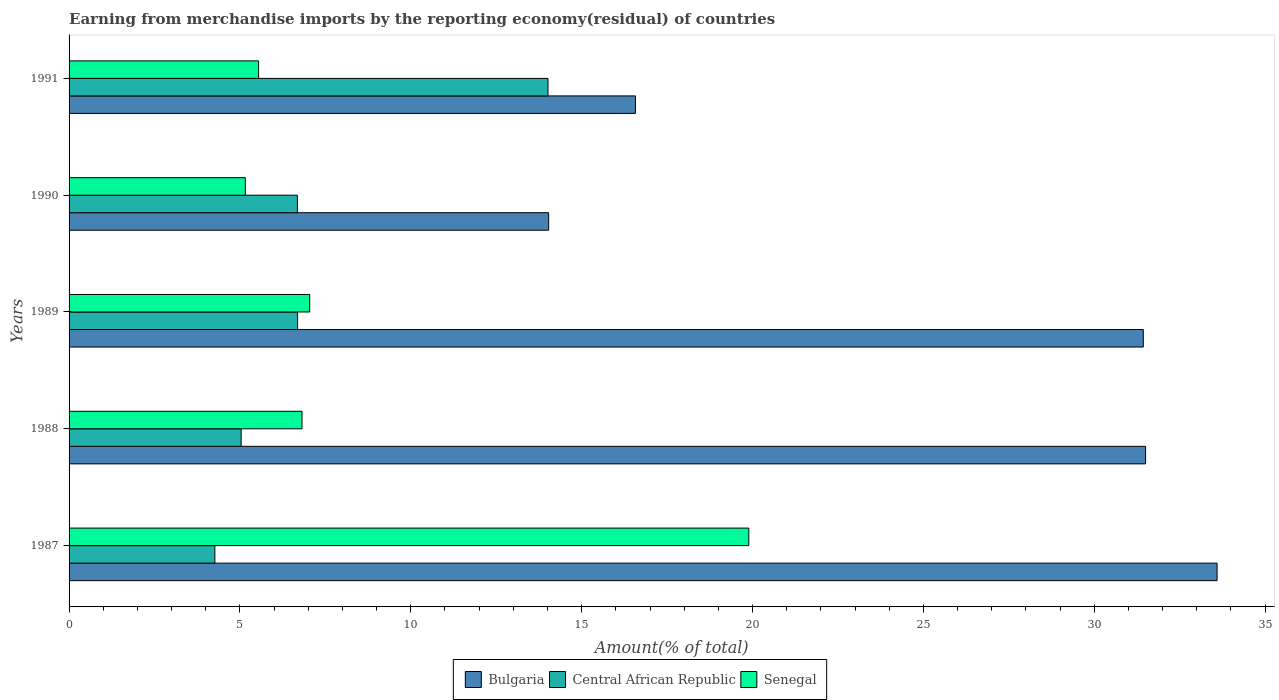How many different coloured bars are there?
Make the answer very short. 3. How many groups of bars are there?
Provide a short and direct response. 5. Are the number of bars per tick equal to the number of legend labels?
Ensure brevity in your answer.  Yes. Are the number of bars on each tick of the Y-axis equal?
Keep it short and to the point. Yes. How many bars are there on the 2nd tick from the bottom?
Ensure brevity in your answer.  3. In how many cases, is the number of bars for a given year not equal to the number of legend labels?
Offer a very short reply. 0. What is the percentage of amount earned from merchandise imports in Senegal in 1989?
Give a very brief answer. 7.04. Across all years, what is the maximum percentage of amount earned from merchandise imports in Senegal?
Your answer should be very brief. 19.89. Across all years, what is the minimum percentage of amount earned from merchandise imports in Bulgaria?
Offer a terse response. 14.03. In which year was the percentage of amount earned from merchandise imports in Senegal maximum?
Keep it short and to the point. 1987. In which year was the percentage of amount earned from merchandise imports in Senegal minimum?
Make the answer very short. 1990. What is the total percentage of amount earned from merchandise imports in Bulgaria in the graph?
Make the answer very short. 127.14. What is the difference between the percentage of amount earned from merchandise imports in Senegal in 1987 and that in 1988?
Offer a very short reply. 13.07. What is the difference between the percentage of amount earned from merchandise imports in Senegal in 1990 and the percentage of amount earned from merchandise imports in Central African Republic in 1991?
Offer a terse response. -8.86. What is the average percentage of amount earned from merchandise imports in Central African Republic per year?
Ensure brevity in your answer.  7.34. In the year 1989, what is the difference between the percentage of amount earned from merchandise imports in Bulgaria and percentage of amount earned from merchandise imports in Central African Republic?
Your answer should be compact. 24.75. In how many years, is the percentage of amount earned from merchandise imports in Bulgaria greater than 21 %?
Ensure brevity in your answer.  3. What is the ratio of the percentage of amount earned from merchandise imports in Senegal in 1987 to that in 1991?
Ensure brevity in your answer.  3.59. Is the percentage of amount earned from merchandise imports in Bulgaria in 1987 less than that in 1991?
Offer a terse response. No. What is the difference between the highest and the second highest percentage of amount earned from merchandise imports in Central African Republic?
Your answer should be very brief. 7.33. What is the difference between the highest and the lowest percentage of amount earned from merchandise imports in Bulgaria?
Offer a very short reply. 19.56. Is the sum of the percentage of amount earned from merchandise imports in Bulgaria in 1987 and 1991 greater than the maximum percentage of amount earned from merchandise imports in Central African Republic across all years?
Your response must be concise. Yes. What does the 2nd bar from the bottom in 1991 represents?
Provide a succinct answer. Central African Republic. Is it the case that in every year, the sum of the percentage of amount earned from merchandise imports in Bulgaria and percentage of amount earned from merchandise imports in Senegal is greater than the percentage of amount earned from merchandise imports in Central African Republic?
Your answer should be very brief. Yes. How many bars are there?
Offer a terse response. 15. Are all the bars in the graph horizontal?
Your answer should be compact. Yes. How many years are there in the graph?
Provide a short and direct response. 5. Does the graph contain grids?
Provide a succinct answer. No. Where does the legend appear in the graph?
Make the answer very short. Bottom center. How are the legend labels stacked?
Your answer should be very brief. Horizontal. What is the title of the graph?
Provide a succinct answer. Earning from merchandise imports by the reporting economy(residual) of countries. What is the label or title of the X-axis?
Offer a terse response. Amount(% of total). What is the Amount(% of total) in Bulgaria in 1987?
Keep it short and to the point. 33.59. What is the Amount(% of total) in Central African Republic in 1987?
Provide a succinct answer. 4.27. What is the Amount(% of total) of Senegal in 1987?
Offer a terse response. 19.89. What is the Amount(% of total) in Bulgaria in 1988?
Your answer should be very brief. 31.5. What is the Amount(% of total) of Central African Republic in 1988?
Ensure brevity in your answer.  5.04. What is the Amount(% of total) in Senegal in 1988?
Make the answer very short. 6.82. What is the Amount(% of total) in Bulgaria in 1989?
Ensure brevity in your answer.  31.44. What is the Amount(% of total) of Central African Republic in 1989?
Make the answer very short. 6.69. What is the Amount(% of total) in Senegal in 1989?
Your answer should be very brief. 7.04. What is the Amount(% of total) in Bulgaria in 1990?
Keep it short and to the point. 14.03. What is the Amount(% of total) in Central African Republic in 1990?
Offer a very short reply. 6.68. What is the Amount(% of total) in Senegal in 1990?
Keep it short and to the point. 5.16. What is the Amount(% of total) of Bulgaria in 1991?
Ensure brevity in your answer.  16.58. What is the Amount(% of total) in Central African Republic in 1991?
Give a very brief answer. 14.02. What is the Amount(% of total) in Senegal in 1991?
Your answer should be compact. 5.55. Across all years, what is the maximum Amount(% of total) of Bulgaria?
Give a very brief answer. 33.59. Across all years, what is the maximum Amount(% of total) in Central African Republic?
Your response must be concise. 14.02. Across all years, what is the maximum Amount(% of total) of Senegal?
Offer a terse response. 19.89. Across all years, what is the minimum Amount(% of total) in Bulgaria?
Make the answer very short. 14.03. Across all years, what is the minimum Amount(% of total) in Central African Republic?
Offer a very short reply. 4.27. Across all years, what is the minimum Amount(% of total) in Senegal?
Provide a succinct answer. 5.16. What is the total Amount(% of total) in Bulgaria in the graph?
Provide a succinct answer. 127.14. What is the total Amount(% of total) of Central African Republic in the graph?
Offer a very short reply. 36.69. What is the total Amount(% of total) in Senegal in the graph?
Ensure brevity in your answer.  44.45. What is the difference between the Amount(% of total) of Bulgaria in 1987 and that in 1988?
Your answer should be very brief. 2.09. What is the difference between the Amount(% of total) in Central African Republic in 1987 and that in 1988?
Keep it short and to the point. -0.77. What is the difference between the Amount(% of total) of Senegal in 1987 and that in 1988?
Provide a succinct answer. 13.07. What is the difference between the Amount(% of total) in Bulgaria in 1987 and that in 1989?
Your response must be concise. 2.16. What is the difference between the Amount(% of total) of Central African Republic in 1987 and that in 1989?
Your answer should be very brief. -2.42. What is the difference between the Amount(% of total) in Senegal in 1987 and that in 1989?
Give a very brief answer. 12.85. What is the difference between the Amount(% of total) in Bulgaria in 1987 and that in 1990?
Offer a terse response. 19.56. What is the difference between the Amount(% of total) of Central African Republic in 1987 and that in 1990?
Give a very brief answer. -2.42. What is the difference between the Amount(% of total) of Senegal in 1987 and that in 1990?
Your answer should be very brief. 14.73. What is the difference between the Amount(% of total) of Bulgaria in 1987 and that in 1991?
Offer a terse response. 17.02. What is the difference between the Amount(% of total) in Central African Republic in 1987 and that in 1991?
Your answer should be very brief. -9.75. What is the difference between the Amount(% of total) in Senegal in 1987 and that in 1991?
Offer a very short reply. 14.35. What is the difference between the Amount(% of total) in Bulgaria in 1988 and that in 1989?
Ensure brevity in your answer.  0.07. What is the difference between the Amount(% of total) of Central African Republic in 1988 and that in 1989?
Offer a very short reply. -1.65. What is the difference between the Amount(% of total) of Senegal in 1988 and that in 1989?
Offer a very short reply. -0.23. What is the difference between the Amount(% of total) of Bulgaria in 1988 and that in 1990?
Offer a very short reply. 17.47. What is the difference between the Amount(% of total) in Central African Republic in 1988 and that in 1990?
Offer a very short reply. -1.65. What is the difference between the Amount(% of total) in Senegal in 1988 and that in 1990?
Offer a terse response. 1.66. What is the difference between the Amount(% of total) in Bulgaria in 1988 and that in 1991?
Ensure brevity in your answer.  14.93. What is the difference between the Amount(% of total) in Central African Republic in 1988 and that in 1991?
Your answer should be compact. -8.98. What is the difference between the Amount(% of total) of Senegal in 1988 and that in 1991?
Keep it short and to the point. 1.27. What is the difference between the Amount(% of total) of Bulgaria in 1989 and that in 1990?
Keep it short and to the point. 17.4. What is the difference between the Amount(% of total) of Central African Republic in 1989 and that in 1990?
Your answer should be very brief. 0.01. What is the difference between the Amount(% of total) in Senegal in 1989 and that in 1990?
Give a very brief answer. 1.88. What is the difference between the Amount(% of total) in Bulgaria in 1989 and that in 1991?
Your answer should be very brief. 14.86. What is the difference between the Amount(% of total) in Central African Republic in 1989 and that in 1991?
Your answer should be compact. -7.33. What is the difference between the Amount(% of total) of Senegal in 1989 and that in 1991?
Provide a succinct answer. 1.5. What is the difference between the Amount(% of total) of Bulgaria in 1990 and that in 1991?
Ensure brevity in your answer.  -2.54. What is the difference between the Amount(% of total) in Central African Republic in 1990 and that in 1991?
Give a very brief answer. -7.33. What is the difference between the Amount(% of total) of Senegal in 1990 and that in 1991?
Keep it short and to the point. -0.39. What is the difference between the Amount(% of total) in Bulgaria in 1987 and the Amount(% of total) in Central African Republic in 1988?
Offer a terse response. 28.56. What is the difference between the Amount(% of total) in Bulgaria in 1987 and the Amount(% of total) in Senegal in 1988?
Give a very brief answer. 26.78. What is the difference between the Amount(% of total) in Central African Republic in 1987 and the Amount(% of total) in Senegal in 1988?
Your answer should be compact. -2.55. What is the difference between the Amount(% of total) of Bulgaria in 1987 and the Amount(% of total) of Central African Republic in 1989?
Your answer should be very brief. 26.91. What is the difference between the Amount(% of total) of Bulgaria in 1987 and the Amount(% of total) of Senegal in 1989?
Offer a very short reply. 26.55. What is the difference between the Amount(% of total) of Central African Republic in 1987 and the Amount(% of total) of Senegal in 1989?
Give a very brief answer. -2.78. What is the difference between the Amount(% of total) of Bulgaria in 1987 and the Amount(% of total) of Central African Republic in 1990?
Your answer should be compact. 26.91. What is the difference between the Amount(% of total) in Bulgaria in 1987 and the Amount(% of total) in Senegal in 1990?
Your answer should be very brief. 28.44. What is the difference between the Amount(% of total) of Central African Republic in 1987 and the Amount(% of total) of Senegal in 1990?
Your response must be concise. -0.89. What is the difference between the Amount(% of total) of Bulgaria in 1987 and the Amount(% of total) of Central African Republic in 1991?
Offer a terse response. 19.58. What is the difference between the Amount(% of total) in Bulgaria in 1987 and the Amount(% of total) in Senegal in 1991?
Your response must be concise. 28.05. What is the difference between the Amount(% of total) of Central African Republic in 1987 and the Amount(% of total) of Senegal in 1991?
Ensure brevity in your answer.  -1.28. What is the difference between the Amount(% of total) of Bulgaria in 1988 and the Amount(% of total) of Central African Republic in 1989?
Ensure brevity in your answer.  24.82. What is the difference between the Amount(% of total) of Bulgaria in 1988 and the Amount(% of total) of Senegal in 1989?
Provide a succinct answer. 24.46. What is the difference between the Amount(% of total) in Central African Republic in 1988 and the Amount(% of total) in Senegal in 1989?
Provide a short and direct response. -2.01. What is the difference between the Amount(% of total) of Bulgaria in 1988 and the Amount(% of total) of Central African Republic in 1990?
Provide a short and direct response. 24.82. What is the difference between the Amount(% of total) in Bulgaria in 1988 and the Amount(% of total) in Senegal in 1990?
Provide a succinct answer. 26.34. What is the difference between the Amount(% of total) in Central African Republic in 1988 and the Amount(% of total) in Senegal in 1990?
Provide a short and direct response. -0.12. What is the difference between the Amount(% of total) in Bulgaria in 1988 and the Amount(% of total) in Central African Republic in 1991?
Keep it short and to the point. 17.49. What is the difference between the Amount(% of total) in Bulgaria in 1988 and the Amount(% of total) in Senegal in 1991?
Provide a succinct answer. 25.96. What is the difference between the Amount(% of total) of Central African Republic in 1988 and the Amount(% of total) of Senegal in 1991?
Keep it short and to the point. -0.51. What is the difference between the Amount(% of total) of Bulgaria in 1989 and the Amount(% of total) of Central African Republic in 1990?
Your response must be concise. 24.75. What is the difference between the Amount(% of total) in Bulgaria in 1989 and the Amount(% of total) in Senegal in 1990?
Keep it short and to the point. 26.28. What is the difference between the Amount(% of total) in Central African Republic in 1989 and the Amount(% of total) in Senegal in 1990?
Make the answer very short. 1.53. What is the difference between the Amount(% of total) of Bulgaria in 1989 and the Amount(% of total) of Central African Republic in 1991?
Your answer should be very brief. 17.42. What is the difference between the Amount(% of total) in Bulgaria in 1989 and the Amount(% of total) in Senegal in 1991?
Your answer should be very brief. 25.89. What is the difference between the Amount(% of total) of Central African Republic in 1989 and the Amount(% of total) of Senegal in 1991?
Keep it short and to the point. 1.14. What is the difference between the Amount(% of total) of Bulgaria in 1990 and the Amount(% of total) of Central African Republic in 1991?
Keep it short and to the point. 0.02. What is the difference between the Amount(% of total) of Bulgaria in 1990 and the Amount(% of total) of Senegal in 1991?
Provide a short and direct response. 8.49. What is the difference between the Amount(% of total) in Central African Republic in 1990 and the Amount(% of total) in Senegal in 1991?
Give a very brief answer. 1.14. What is the average Amount(% of total) in Bulgaria per year?
Keep it short and to the point. 25.43. What is the average Amount(% of total) of Central African Republic per year?
Make the answer very short. 7.34. What is the average Amount(% of total) in Senegal per year?
Ensure brevity in your answer.  8.89. In the year 1987, what is the difference between the Amount(% of total) in Bulgaria and Amount(% of total) in Central African Republic?
Your answer should be very brief. 29.33. In the year 1987, what is the difference between the Amount(% of total) in Bulgaria and Amount(% of total) in Senegal?
Ensure brevity in your answer.  13.7. In the year 1987, what is the difference between the Amount(% of total) of Central African Republic and Amount(% of total) of Senegal?
Keep it short and to the point. -15.62. In the year 1988, what is the difference between the Amount(% of total) of Bulgaria and Amount(% of total) of Central African Republic?
Your answer should be very brief. 26.47. In the year 1988, what is the difference between the Amount(% of total) in Bulgaria and Amount(% of total) in Senegal?
Ensure brevity in your answer.  24.69. In the year 1988, what is the difference between the Amount(% of total) in Central African Republic and Amount(% of total) in Senegal?
Provide a succinct answer. -1.78. In the year 1989, what is the difference between the Amount(% of total) of Bulgaria and Amount(% of total) of Central African Republic?
Make the answer very short. 24.75. In the year 1989, what is the difference between the Amount(% of total) of Bulgaria and Amount(% of total) of Senegal?
Provide a short and direct response. 24.39. In the year 1989, what is the difference between the Amount(% of total) of Central African Republic and Amount(% of total) of Senegal?
Offer a very short reply. -0.35. In the year 1990, what is the difference between the Amount(% of total) in Bulgaria and Amount(% of total) in Central African Republic?
Ensure brevity in your answer.  7.35. In the year 1990, what is the difference between the Amount(% of total) in Bulgaria and Amount(% of total) in Senegal?
Provide a short and direct response. 8.88. In the year 1990, what is the difference between the Amount(% of total) of Central African Republic and Amount(% of total) of Senegal?
Your answer should be compact. 1.52. In the year 1991, what is the difference between the Amount(% of total) in Bulgaria and Amount(% of total) in Central African Republic?
Ensure brevity in your answer.  2.56. In the year 1991, what is the difference between the Amount(% of total) of Bulgaria and Amount(% of total) of Senegal?
Give a very brief answer. 11.03. In the year 1991, what is the difference between the Amount(% of total) of Central African Republic and Amount(% of total) of Senegal?
Ensure brevity in your answer.  8.47. What is the ratio of the Amount(% of total) in Bulgaria in 1987 to that in 1988?
Give a very brief answer. 1.07. What is the ratio of the Amount(% of total) of Central African Republic in 1987 to that in 1988?
Provide a succinct answer. 0.85. What is the ratio of the Amount(% of total) in Senegal in 1987 to that in 1988?
Ensure brevity in your answer.  2.92. What is the ratio of the Amount(% of total) in Bulgaria in 1987 to that in 1989?
Your response must be concise. 1.07. What is the ratio of the Amount(% of total) of Central African Republic in 1987 to that in 1989?
Your response must be concise. 0.64. What is the ratio of the Amount(% of total) in Senegal in 1987 to that in 1989?
Your answer should be very brief. 2.82. What is the ratio of the Amount(% of total) of Bulgaria in 1987 to that in 1990?
Your response must be concise. 2.39. What is the ratio of the Amount(% of total) in Central African Republic in 1987 to that in 1990?
Ensure brevity in your answer.  0.64. What is the ratio of the Amount(% of total) in Senegal in 1987 to that in 1990?
Give a very brief answer. 3.86. What is the ratio of the Amount(% of total) in Bulgaria in 1987 to that in 1991?
Your answer should be very brief. 2.03. What is the ratio of the Amount(% of total) in Central African Republic in 1987 to that in 1991?
Provide a short and direct response. 0.3. What is the ratio of the Amount(% of total) of Senegal in 1987 to that in 1991?
Provide a short and direct response. 3.59. What is the ratio of the Amount(% of total) of Central African Republic in 1988 to that in 1989?
Keep it short and to the point. 0.75. What is the ratio of the Amount(% of total) in Senegal in 1988 to that in 1989?
Offer a terse response. 0.97. What is the ratio of the Amount(% of total) of Bulgaria in 1988 to that in 1990?
Offer a very short reply. 2.24. What is the ratio of the Amount(% of total) in Central African Republic in 1988 to that in 1990?
Provide a succinct answer. 0.75. What is the ratio of the Amount(% of total) in Senegal in 1988 to that in 1990?
Your answer should be compact. 1.32. What is the ratio of the Amount(% of total) of Bulgaria in 1988 to that in 1991?
Your answer should be very brief. 1.9. What is the ratio of the Amount(% of total) of Central African Republic in 1988 to that in 1991?
Keep it short and to the point. 0.36. What is the ratio of the Amount(% of total) of Senegal in 1988 to that in 1991?
Ensure brevity in your answer.  1.23. What is the ratio of the Amount(% of total) in Bulgaria in 1989 to that in 1990?
Your answer should be compact. 2.24. What is the ratio of the Amount(% of total) of Central African Republic in 1989 to that in 1990?
Your answer should be compact. 1. What is the ratio of the Amount(% of total) in Senegal in 1989 to that in 1990?
Give a very brief answer. 1.37. What is the ratio of the Amount(% of total) of Bulgaria in 1989 to that in 1991?
Make the answer very short. 1.9. What is the ratio of the Amount(% of total) in Central African Republic in 1989 to that in 1991?
Give a very brief answer. 0.48. What is the ratio of the Amount(% of total) in Senegal in 1989 to that in 1991?
Provide a short and direct response. 1.27. What is the ratio of the Amount(% of total) in Bulgaria in 1990 to that in 1991?
Offer a very short reply. 0.85. What is the ratio of the Amount(% of total) in Central African Republic in 1990 to that in 1991?
Provide a short and direct response. 0.48. What is the ratio of the Amount(% of total) in Senegal in 1990 to that in 1991?
Provide a short and direct response. 0.93. What is the difference between the highest and the second highest Amount(% of total) of Bulgaria?
Keep it short and to the point. 2.09. What is the difference between the highest and the second highest Amount(% of total) of Central African Republic?
Make the answer very short. 7.33. What is the difference between the highest and the second highest Amount(% of total) in Senegal?
Provide a short and direct response. 12.85. What is the difference between the highest and the lowest Amount(% of total) of Bulgaria?
Your answer should be very brief. 19.56. What is the difference between the highest and the lowest Amount(% of total) in Central African Republic?
Your answer should be compact. 9.75. What is the difference between the highest and the lowest Amount(% of total) in Senegal?
Ensure brevity in your answer.  14.73. 